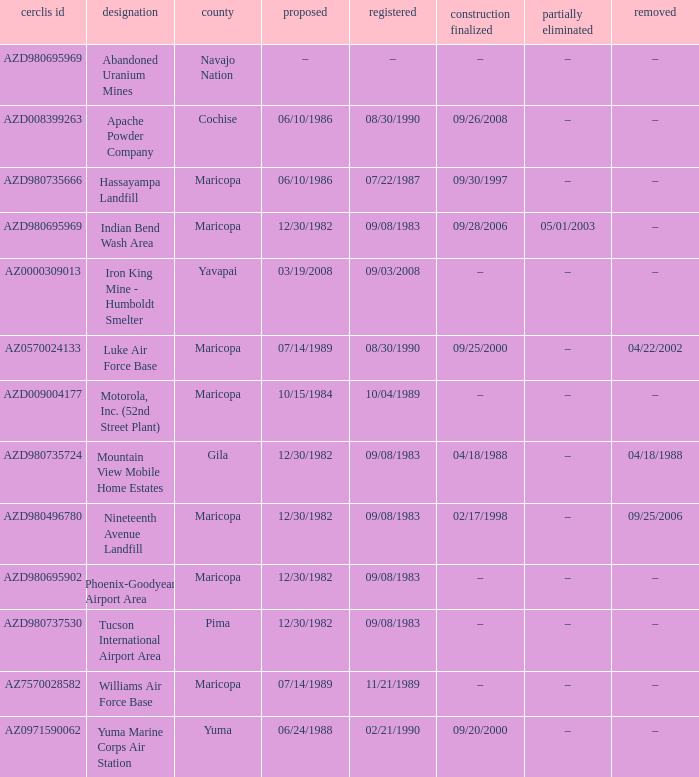When was the site partially deleted when the cerclis id is az7570028582? –. 